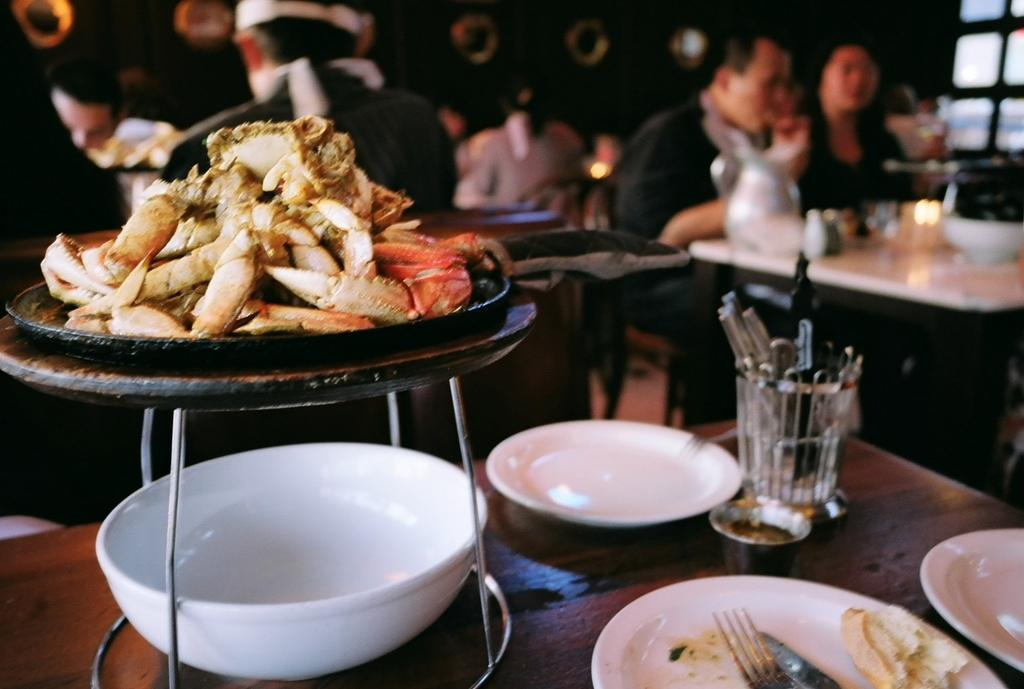What type of furniture is visible in the image? There are tables in the image. What can be found on the tables? Food items, plates, bowls, and glasses are present on the tables. Are there any people in the image? Yes, there are people in the image. What can be observed about the background of the image? The background of the image is blurred. What type of cream is being used to make the noise in the image? There is no cream or noise present in the image. Can you see a hook hanging from the ceiling in the image? There is no hook visible in the image. 